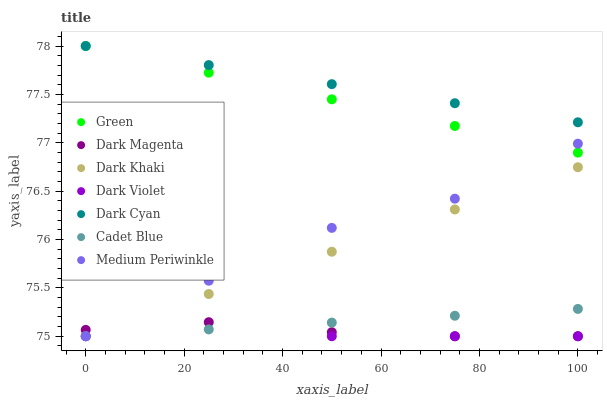Does Dark Magenta have the minimum area under the curve?
Answer yes or no. Yes. Does Dark Cyan have the maximum area under the curve?
Answer yes or no. Yes. Does Medium Periwinkle have the minimum area under the curve?
Answer yes or no. No. Does Medium Periwinkle have the maximum area under the curve?
Answer yes or no. No. Is Dark Khaki the smoothest?
Answer yes or no. Yes. Is Dark Violet the roughest?
Answer yes or no. Yes. Is Dark Magenta the smoothest?
Answer yes or no. No. Is Dark Magenta the roughest?
Answer yes or no. No. Does Cadet Blue have the lowest value?
Answer yes or no. Yes. Does Green have the lowest value?
Answer yes or no. No. Does Dark Cyan have the highest value?
Answer yes or no. Yes. Does Medium Periwinkle have the highest value?
Answer yes or no. No. Is Dark Violet less than Dark Cyan?
Answer yes or no. Yes. Is Green greater than Dark Khaki?
Answer yes or no. Yes. Does Medium Periwinkle intersect Green?
Answer yes or no. Yes. Is Medium Periwinkle less than Green?
Answer yes or no. No. Is Medium Periwinkle greater than Green?
Answer yes or no. No. Does Dark Violet intersect Dark Cyan?
Answer yes or no. No. 